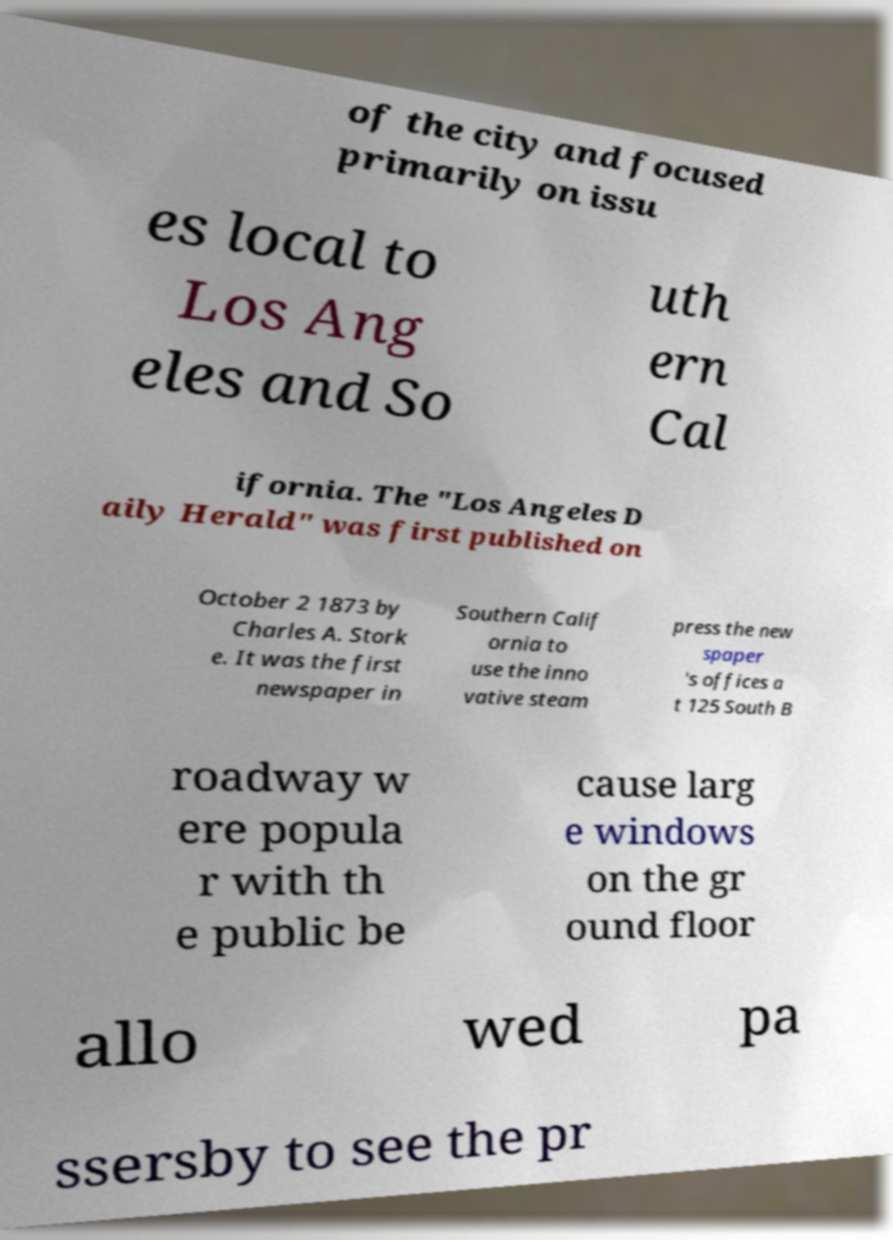Please identify and transcribe the text found in this image. of the city and focused primarily on issu es local to Los Ang eles and So uth ern Cal ifornia. The "Los Angeles D aily Herald" was first published on October 2 1873 by Charles A. Stork e. It was the first newspaper in Southern Calif ornia to use the inno vative steam press the new spaper 's offices a t 125 South B roadway w ere popula r with th e public be cause larg e windows on the gr ound floor allo wed pa ssersby to see the pr 